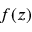<formula> <loc_0><loc_0><loc_500><loc_500>f ( z )</formula> 